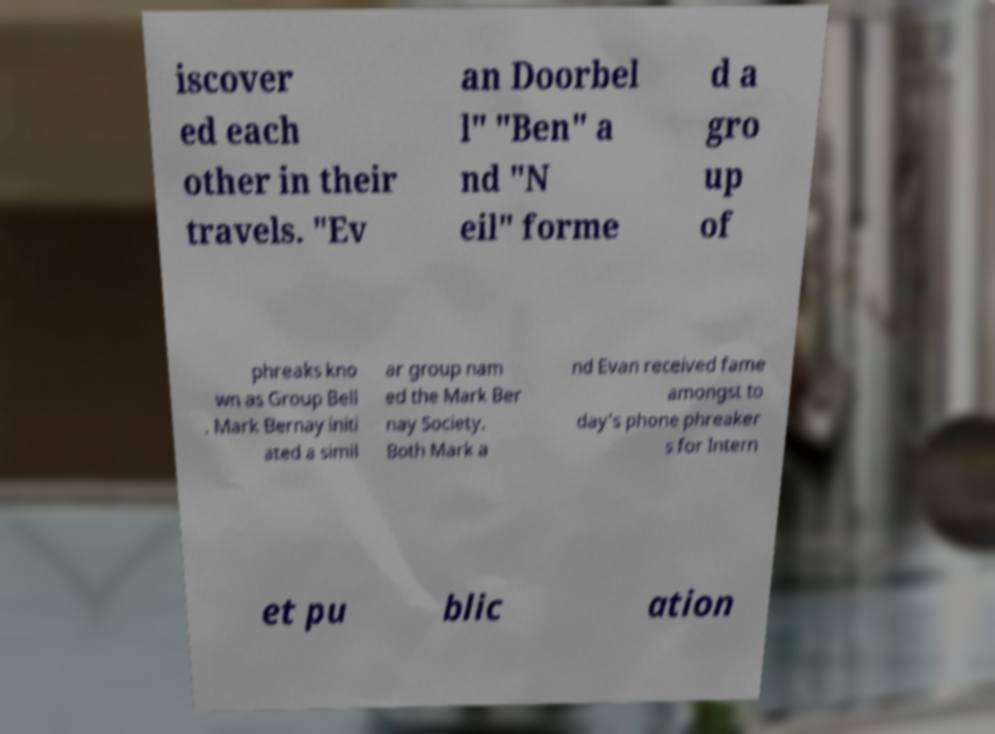There's text embedded in this image that I need extracted. Can you transcribe it verbatim? iscover ed each other in their travels. "Ev an Doorbel l" "Ben" a nd "N eil" forme d a gro up of phreaks kno wn as Group Bell . Mark Bernay initi ated a simil ar group nam ed the Mark Ber nay Society. Both Mark a nd Evan received fame amongst to day's phone phreaker s for Intern et pu blic ation 